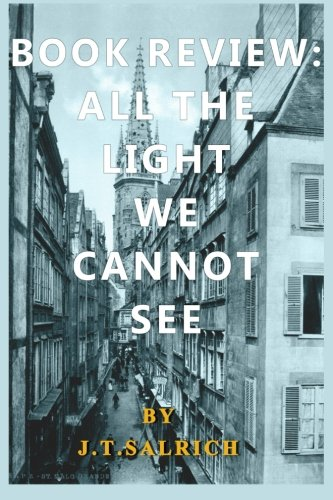What type of book is this? This is a fiction book, particularly in the genre of Literature & Fiction, known for its beautiful narrative and depth of storytelling. 